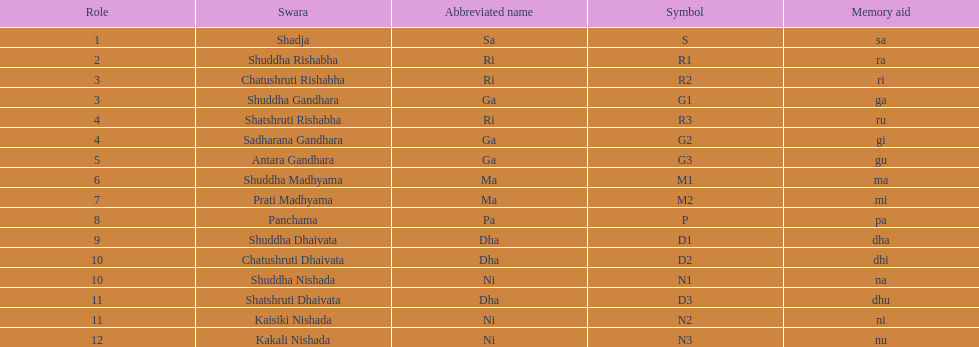Which swara holds the last position? Kakali Nishada. 